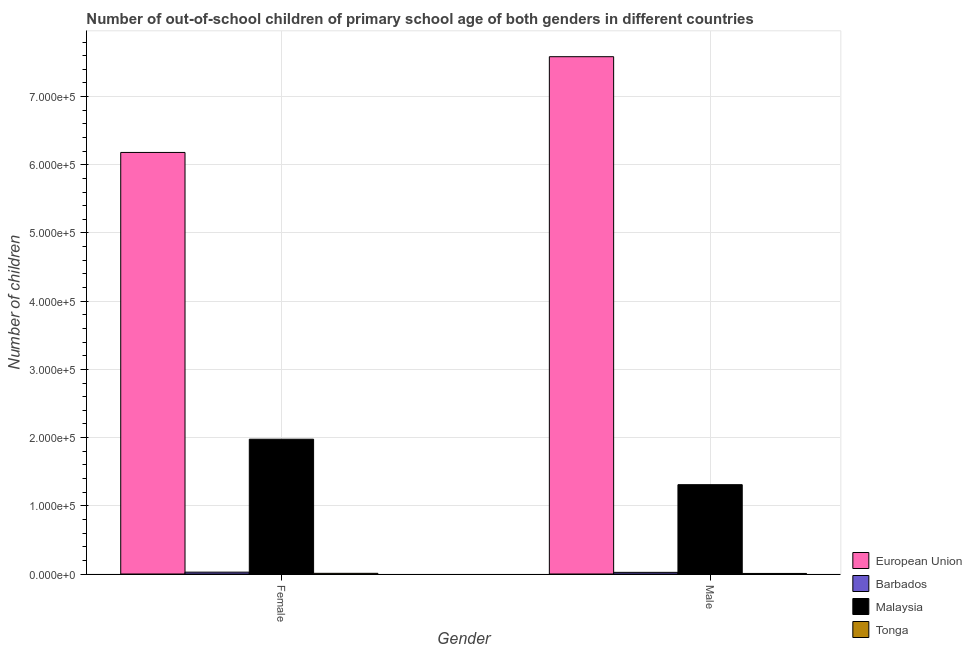Are the number of bars per tick equal to the number of legend labels?
Provide a short and direct response. Yes. How many bars are there on the 2nd tick from the right?
Offer a terse response. 4. What is the label of the 2nd group of bars from the left?
Your answer should be compact. Male. What is the number of female out-of-school students in European Union?
Make the answer very short. 6.18e+05. Across all countries, what is the maximum number of female out-of-school students?
Make the answer very short. 6.18e+05. Across all countries, what is the minimum number of male out-of-school students?
Your answer should be very brief. 827. In which country was the number of male out-of-school students maximum?
Give a very brief answer. European Union. In which country was the number of male out-of-school students minimum?
Offer a very short reply. Tonga. What is the total number of female out-of-school students in the graph?
Provide a succinct answer. 8.19e+05. What is the difference between the number of female out-of-school students in European Union and that in Barbados?
Your response must be concise. 6.15e+05. What is the difference between the number of female out-of-school students in European Union and the number of male out-of-school students in Tonga?
Ensure brevity in your answer.  6.17e+05. What is the average number of female out-of-school students per country?
Your response must be concise. 2.05e+05. What is the difference between the number of male out-of-school students and number of female out-of-school students in European Union?
Your response must be concise. 1.40e+05. In how many countries, is the number of male out-of-school students greater than 200000 ?
Offer a terse response. 1. What is the ratio of the number of female out-of-school students in Barbados to that in Malaysia?
Offer a terse response. 0.01. Is the number of male out-of-school students in European Union less than that in Tonga?
Offer a terse response. No. In how many countries, is the number of female out-of-school students greater than the average number of female out-of-school students taken over all countries?
Ensure brevity in your answer.  1. What does the 2nd bar from the left in Female represents?
Ensure brevity in your answer.  Barbados. Are all the bars in the graph horizontal?
Keep it short and to the point. No. How many countries are there in the graph?
Give a very brief answer. 4. Are the values on the major ticks of Y-axis written in scientific E-notation?
Your answer should be compact. Yes. Where does the legend appear in the graph?
Your answer should be compact. Bottom right. How many legend labels are there?
Your answer should be very brief. 4. How are the legend labels stacked?
Your answer should be very brief. Vertical. What is the title of the graph?
Keep it short and to the point. Number of out-of-school children of primary school age of both genders in different countries. Does "Kazakhstan" appear as one of the legend labels in the graph?
Provide a succinct answer. No. What is the label or title of the Y-axis?
Your response must be concise. Number of children. What is the Number of children of European Union in Female?
Ensure brevity in your answer.  6.18e+05. What is the Number of children in Barbados in Female?
Keep it short and to the point. 2721. What is the Number of children of Malaysia in Female?
Offer a terse response. 1.98e+05. What is the Number of children of Tonga in Female?
Offer a very short reply. 1006. What is the Number of children of European Union in Male?
Offer a very short reply. 7.58e+05. What is the Number of children of Barbados in Male?
Provide a succinct answer. 2413. What is the Number of children of Malaysia in Male?
Provide a succinct answer. 1.31e+05. What is the Number of children in Tonga in Male?
Offer a terse response. 827. Across all Gender, what is the maximum Number of children in European Union?
Your response must be concise. 7.58e+05. Across all Gender, what is the maximum Number of children in Barbados?
Your answer should be compact. 2721. Across all Gender, what is the maximum Number of children in Malaysia?
Your answer should be compact. 1.98e+05. Across all Gender, what is the maximum Number of children in Tonga?
Keep it short and to the point. 1006. Across all Gender, what is the minimum Number of children in European Union?
Provide a succinct answer. 6.18e+05. Across all Gender, what is the minimum Number of children in Barbados?
Ensure brevity in your answer.  2413. Across all Gender, what is the minimum Number of children of Malaysia?
Make the answer very short. 1.31e+05. Across all Gender, what is the minimum Number of children of Tonga?
Your answer should be compact. 827. What is the total Number of children in European Union in the graph?
Keep it short and to the point. 1.38e+06. What is the total Number of children of Barbados in the graph?
Offer a terse response. 5134. What is the total Number of children in Malaysia in the graph?
Ensure brevity in your answer.  3.29e+05. What is the total Number of children of Tonga in the graph?
Your response must be concise. 1833. What is the difference between the Number of children of European Union in Female and that in Male?
Offer a very short reply. -1.40e+05. What is the difference between the Number of children in Barbados in Female and that in Male?
Offer a terse response. 308. What is the difference between the Number of children of Malaysia in Female and that in Male?
Provide a succinct answer. 6.67e+04. What is the difference between the Number of children in Tonga in Female and that in Male?
Your answer should be very brief. 179. What is the difference between the Number of children in European Union in Female and the Number of children in Barbados in Male?
Provide a succinct answer. 6.16e+05. What is the difference between the Number of children in European Union in Female and the Number of children in Malaysia in Male?
Provide a short and direct response. 4.87e+05. What is the difference between the Number of children in European Union in Female and the Number of children in Tonga in Male?
Offer a very short reply. 6.17e+05. What is the difference between the Number of children in Barbados in Female and the Number of children in Malaysia in Male?
Give a very brief answer. -1.28e+05. What is the difference between the Number of children in Barbados in Female and the Number of children in Tonga in Male?
Provide a short and direct response. 1894. What is the difference between the Number of children of Malaysia in Female and the Number of children of Tonga in Male?
Offer a very short reply. 1.97e+05. What is the average Number of children in European Union per Gender?
Offer a very short reply. 6.88e+05. What is the average Number of children of Barbados per Gender?
Your answer should be compact. 2567. What is the average Number of children of Malaysia per Gender?
Your answer should be very brief. 1.64e+05. What is the average Number of children of Tonga per Gender?
Provide a succinct answer. 916.5. What is the difference between the Number of children in European Union and Number of children in Barbados in Female?
Offer a terse response. 6.15e+05. What is the difference between the Number of children of European Union and Number of children of Malaysia in Female?
Provide a succinct answer. 4.20e+05. What is the difference between the Number of children of European Union and Number of children of Tonga in Female?
Keep it short and to the point. 6.17e+05. What is the difference between the Number of children of Barbados and Number of children of Malaysia in Female?
Offer a very short reply. -1.95e+05. What is the difference between the Number of children of Barbados and Number of children of Tonga in Female?
Keep it short and to the point. 1715. What is the difference between the Number of children of Malaysia and Number of children of Tonga in Female?
Provide a short and direct response. 1.97e+05. What is the difference between the Number of children in European Union and Number of children in Barbados in Male?
Your answer should be very brief. 7.56e+05. What is the difference between the Number of children in European Union and Number of children in Malaysia in Male?
Offer a terse response. 6.28e+05. What is the difference between the Number of children of European Union and Number of children of Tonga in Male?
Your answer should be very brief. 7.58e+05. What is the difference between the Number of children in Barbados and Number of children in Malaysia in Male?
Provide a succinct answer. -1.29e+05. What is the difference between the Number of children in Barbados and Number of children in Tonga in Male?
Provide a succinct answer. 1586. What is the difference between the Number of children in Malaysia and Number of children in Tonga in Male?
Offer a terse response. 1.30e+05. What is the ratio of the Number of children in European Union in Female to that in Male?
Keep it short and to the point. 0.81. What is the ratio of the Number of children in Barbados in Female to that in Male?
Offer a very short reply. 1.13. What is the ratio of the Number of children of Malaysia in Female to that in Male?
Ensure brevity in your answer.  1.51. What is the ratio of the Number of children of Tonga in Female to that in Male?
Provide a succinct answer. 1.22. What is the difference between the highest and the second highest Number of children of European Union?
Your answer should be compact. 1.40e+05. What is the difference between the highest and the second highest Number of children of Barbados?
Ensure brevity in your answer.  308. What is the difference between the highest and the second highest Number of children in Malaysia?
Offer a very short reply. 6.67e+04. What is the difference between the highest and the second highest Number of children of Tonga?
Ensure brevity in your answer.  179. What is the difference between the highest and the lowest Number of children in European Union?
Keep it short and to the point. 1.40e+05. What is the difference between the highest and the lowest Number of children of Barbados?
Offer a very short reply. 308. What is the difference between the highest and the lowest Number of children of Malaysia?
Provide a succinct answer. 6.67e+04. What is the difference between the highest and the lowest Number of children of Tonga?
Your response must be concise. 179. 